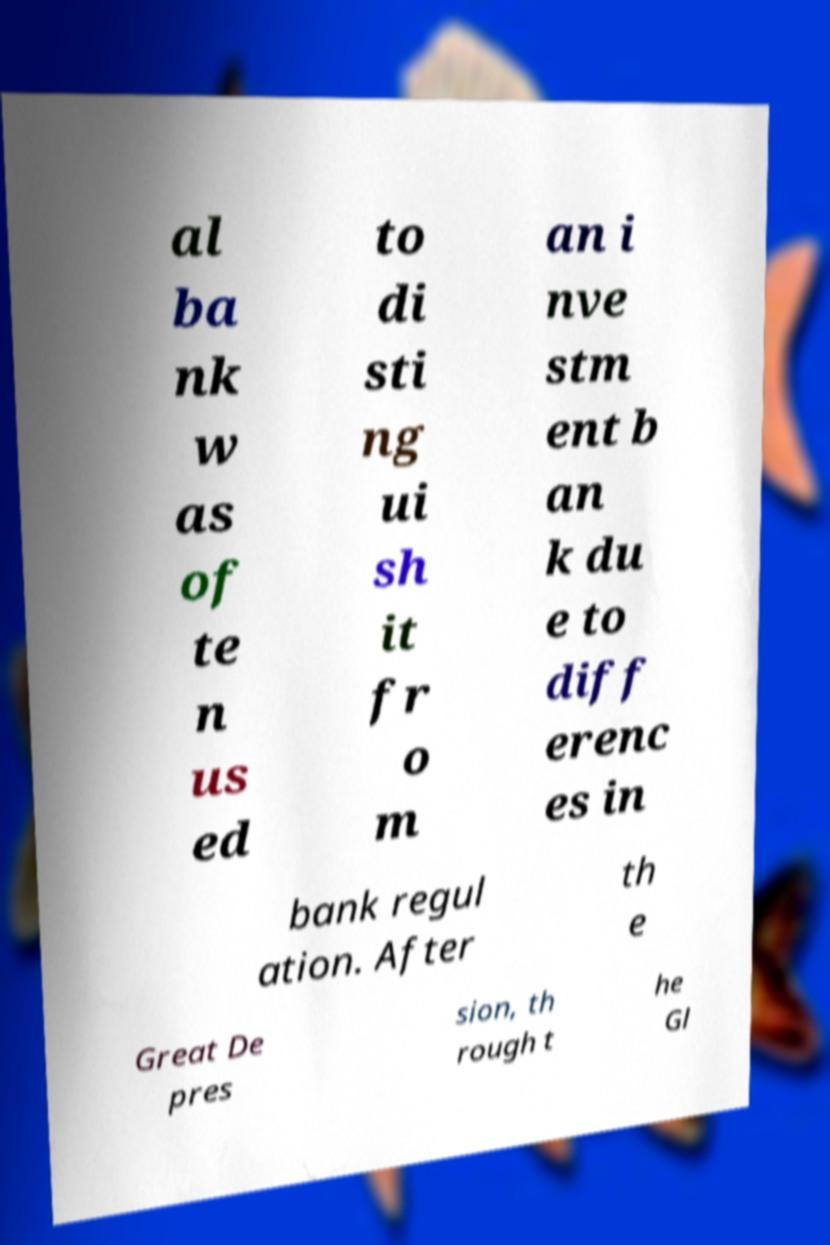Can you read and provide the text displayed in the image?This photo seems to have some interesting text. Can you extract and type it out for me? al ba nk w as of te n us ed to di sti ng ui sh it fr o m an i nve stm ent b an k du e to diff erenc es in bank regul ation. After th e Great De pres sion, th rough t he Gl 